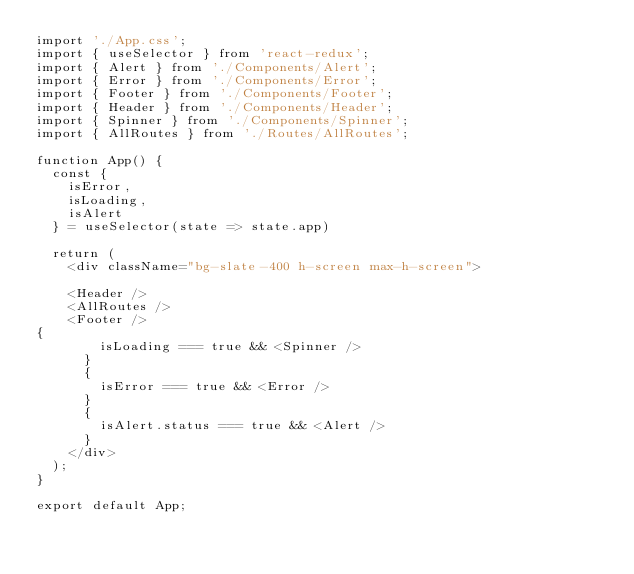Convert code to text. <code><loc_0><loc_0><loc_500><loc_500><_JavaScript_>import './App.css';
import { useSelector } from 'react-redux';
import { Alert } from './Components/Alert';
import { Error } from './Components/Error';
import { Footer } from './Components/Footer';
import { Header } from './Components/Header';
import { Spinner } from './Components/Spinner';
import { AllRoutes } from './Routes/AllRoutes';

function App() {
  const {
    isError,
    isLoading,
    isAlert
  } = useSelector(state => state.app)

  return (
    <div className="bg-slate-400 h-screen max-h-screen">

    <Header />
    <AllRoutes />
    <Footer />
{
        isLoading === true && <Spinner />
      }
      {
        isError === true && <Error />
      }
      {
        isAlert.status === true && <Alert />
      }
    </div>
  );
}

export default App;
</code> 